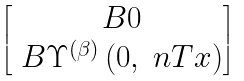Convert formula to latex. <formula><loc_0><loc_0><loc_500><loc_500>\begin{bmatrix} \ B { 0 } \\ \ B { \Upsilon } ^ { \left ( \beta \right ) } \left ( 0 , \ n T x \right ) \end{bmatrix}</formula> 